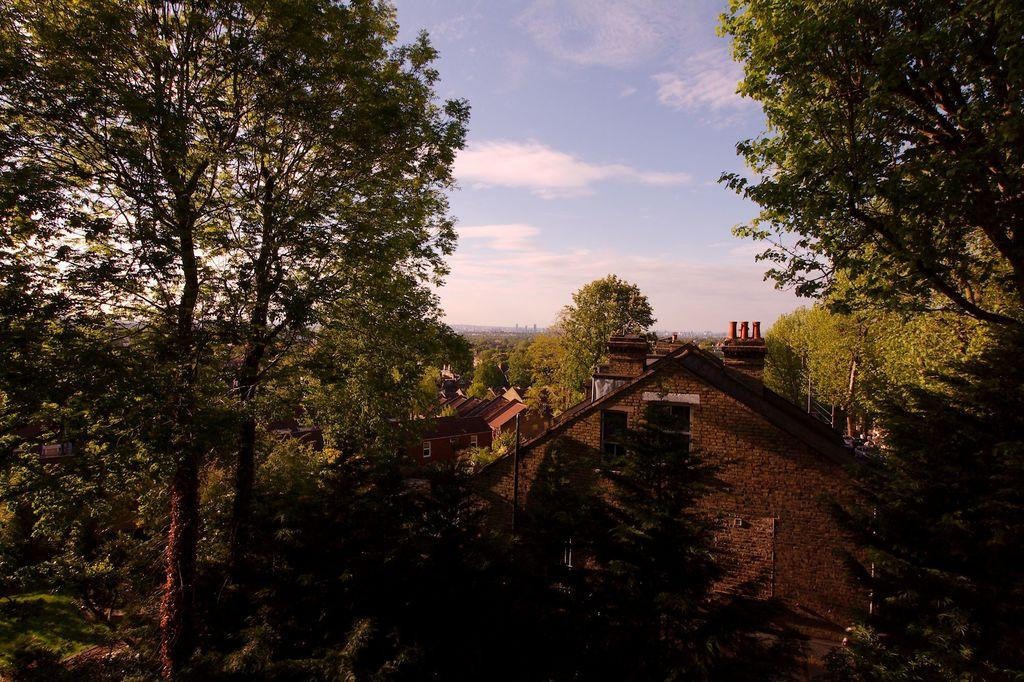How many houses can be seen at the bottom of the image? There are three houses at the bottom of the image. What is located in the middle of the image? There are trees in the middle of the image. What is visible in the background of the image? The sky is visible in the image. What can be seen in the sky? Clouds are present in the sky. Where is the laborer carrying the box on the edge of the image? There is no laborer or box present in the image. What type of edge can be seen in the image? The image does not show any edges; it is a two-dimensional representation of a scene. 